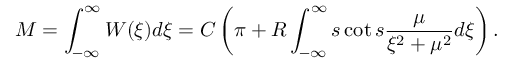<formula> <loc_0><loc_0><loc_500><loc_500>M = \int _ { - \infty } ^ { \infty } W ( \xi ) d \xi = C \left ( \pi + R \int _ { - \infty } ^ { \infty } s \cot s \frac { \mu } { \xi ^ { 2 } + \mu ^ { 2 } } d \xi \right ) .</formula> 